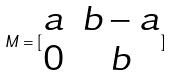Convert formula to latex. <formula><loc_0><loc_0><loc_500><loc_500>M = [ \begin{matrix} a & b - a \\ 0 & b \end{matrix} ]</formula> 